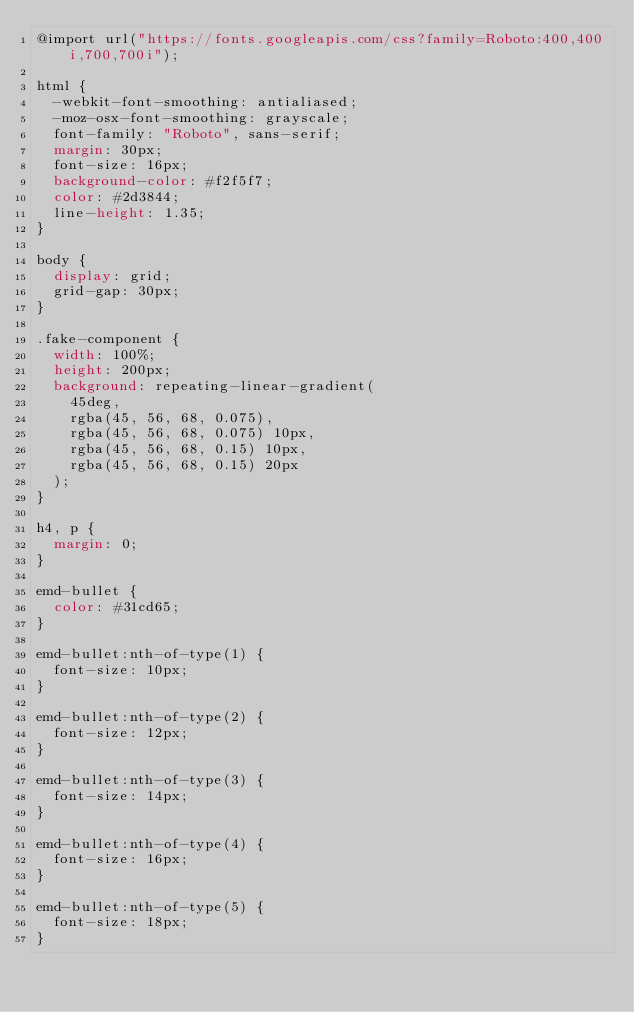Convert code to text. <code><loc_0><loc_0><loc_500><loc_500><_CSS_>@import url("https://fonts.googleapis.com/css?family=Roboto:400,400i,700,700i");

html {
  -webkit-font-smoothing: antialiased;
  -moz-osx-font-smoothing: grayscale;
  font-family: "Roboto", sans-serif;
  margin: 30px;
  font-size: 16px;
  background-color: #f2f5f7;
  color: #2d3844;
  line-height: 1.35;
}

body {
  display: grid;
  grid-gap: 30px;
}

.fake-component {
  width: 100%;
  height: 200px;
  background: repeating-linear-gradient(
    45deg,
    rgba(45, 56, 68, 0.075),
    rgba(45, 56, 68, 0.075) 10px,
    rgba(45, 56, 68, 0.15) 10px,
    rgba(45, 56, 68, 0.15) 20px
  );
}

h4, p {
  margin: 0;
}

emd-bullet {
  color: #31cd65;
}

emd-bullet:nth-of-type(1) {
  font-size: 10px;
}

emd-bullet:nth-of-type(2) {
  font-size: 12px;
}

emd-bullet:nth-of-type(3) {
  font-size: 14px;
}

emd-bullet:nth-of-type(4) {
  font-size: 16px;
}

emd-bullet:nth-of-type(5) {
  font-size: 18px;
}</code> 